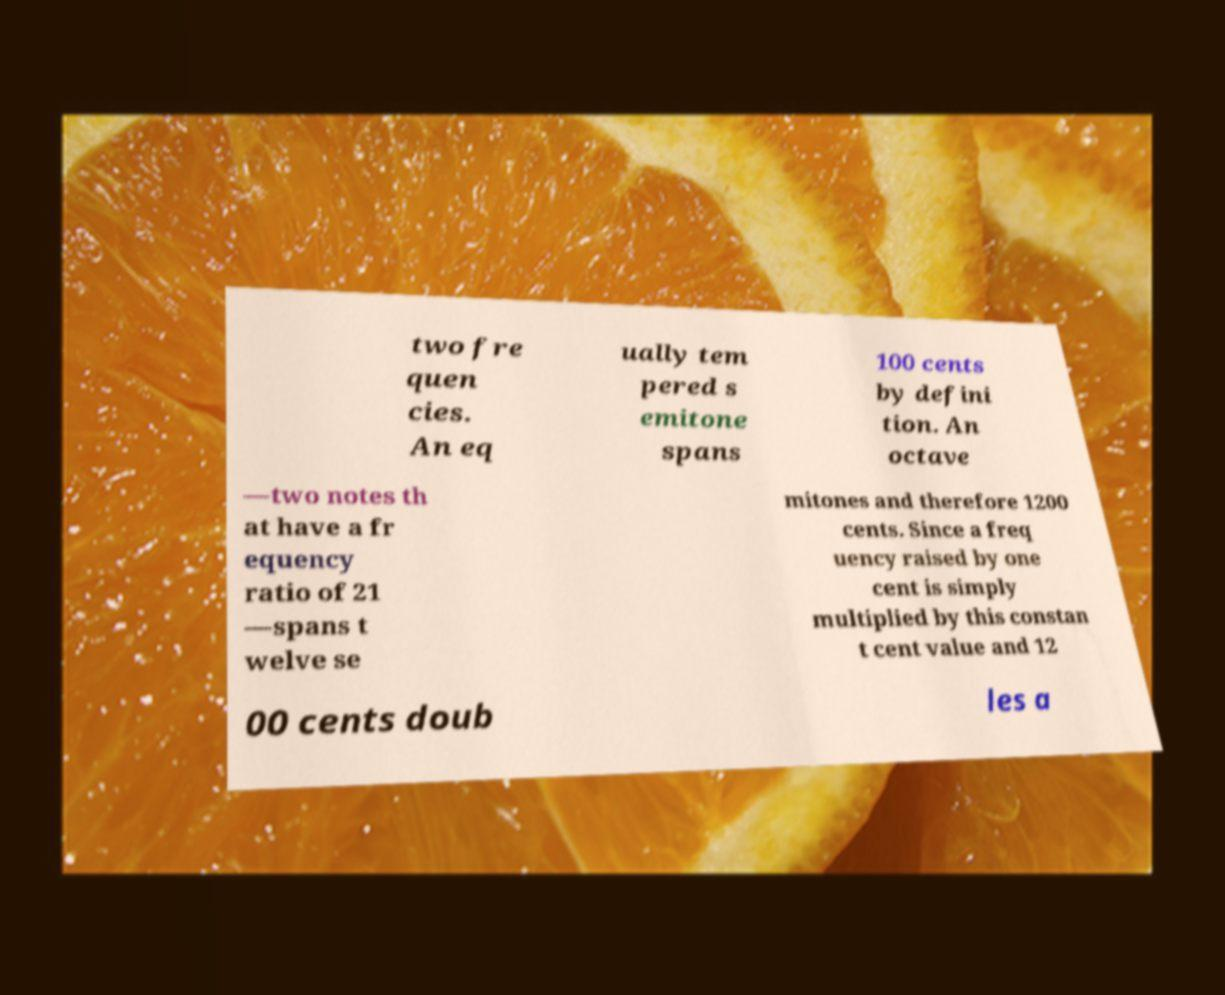For documentation purposes, I need the text within this image transcribed. Could you provide that? two fre quen cies. An eq ually tem pered s emitone spans 100 cents by defini tion. An octave —two notes th at have a fr equency ratio of 21 —spans t welve se mitones and therefore 1200 cents. Since a freq uency raised by one cent is simply multiplied by this constan t cent value and 12 00 cents doub les a 